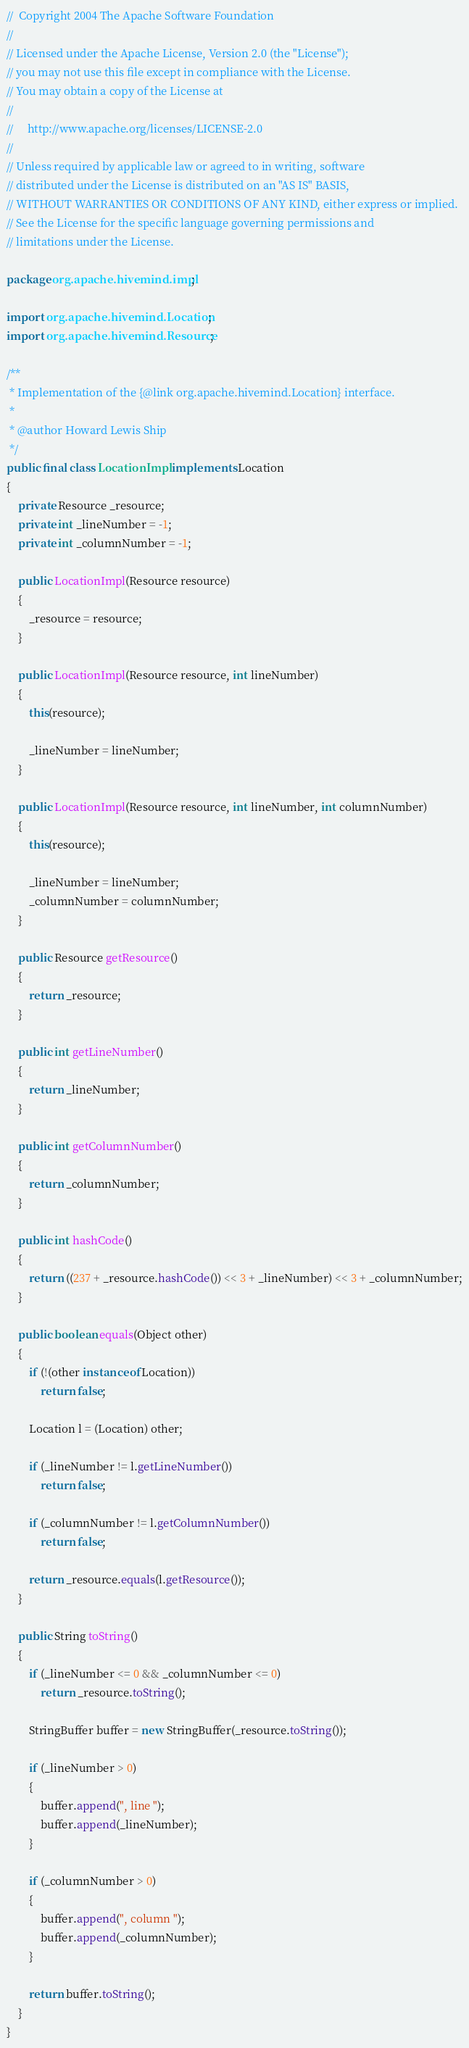Convert code to text. <code><loc_0><loc_0><loc_500><loc_500><_Java_>//  Copyright 2004 The Apache Software Foundation
//
// Licensed under the Apache License, Version 2.0 (the "License");
// you may not use this file except in compliance with the License.
// You may obtain a copy of the License at
//
//     http://www.apache.org/licenses/LICENSE-2.0
//
// Unless required by applicable law or agreed to in writing, software
// distributed under the License is distributed on an "AS IS" BASIS,
// WITHOUT WARRANTIES OR CONDITIONS OF ANY KIND, either express or implied.
// See the License for the specific language governing permissions and
// limitations under the License.

package org.apache.hivemind.impl;

import org.apache.hivemind.Location;
import org.apache.hivemind.Resource;

/**
 * Implementation of the {@link org.apache.hivemind.Location} interface.
 *
 * @author Howard Lewis Ship
 */
public final class LocationImpl implements Location
{
    private Resource _resource;
    private int _lineNumber = -1;
    private int _columnNumber = -1;

    public LocationImpl(Resource resource)
    {
        _resource = resource;
    }

    public LocationImpl(Resource resource, int lineNumber)
    {
        this(resource);

        _lineNumber = lineNumber;
    }

    public LocationImpl(Resource resource, int lineNumber, int columnNumber)
    {
        this(resource);

        _lineNumber = lineNumber;
        _columnNumber = columnNumber;
    }

    public Resource getResource()
    {
        return _resource;
    }

    public int getLineNumber()
    {
        return _lineNumber;
    }

    public int getColumnNumber()
    {
        return _columnNumber;
    }

    public int hashCode()
    {
        return ((237 + _resource.hashCode()) << 3 + _lineNumber) << 3 + _columnNumber;
    }

    public boolean equals(Object other)
    {
        if (!(other instanceof Location))
            return false;

        Location l = (Location) other;

        if (_lineNumber != l.getLineNumber())
            return false;

        if (_columnNumber != l.getColumnNumber())
            return false;

        return _resource.equals(l.getResource());
    }

    public String toString()
    {
        if (_lineNumber <= 0 && _columnNumber <= 0)
            return _resource.toString();

        StringBuffer buffer = new StringBuffer(_resource.toString());

        if (_lineNumber > 0)
        {
            buffer.append(", line ");
            buffer.append(_lineNumber);
        }

        if (_columnNumber > 0)
        {
            buffer.append(", column ");
            buffer.append(_columnNumber);
        }

        return buffer.toString();
    }
}
</code> 